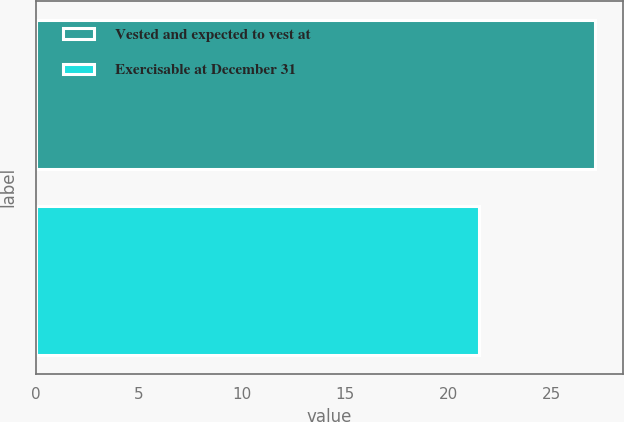Convert chart to OTSL. <chart><loc_0><loc_0><loc_500><loc_500><bar_chart><fcel>Vested and expected to vest at<fcel>Exercisable at December 31<nl><fcel>27.11<fcel>21.47<nl></chart> 